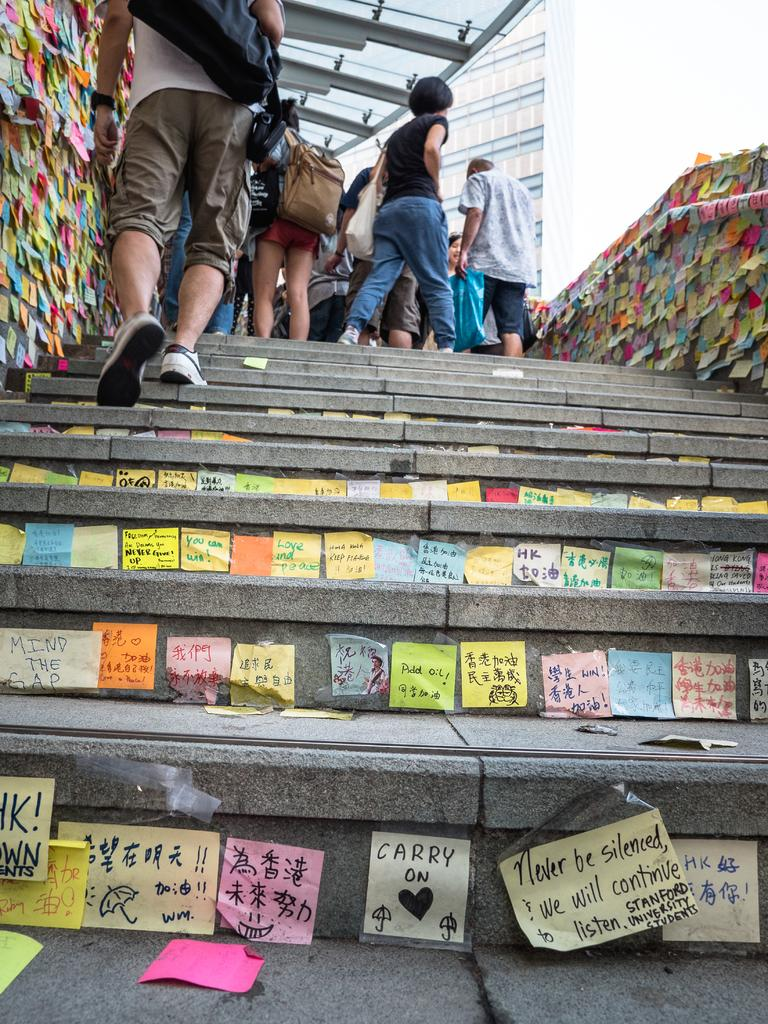<image>
Share a concise interpretation of the image provided. A set of outdoor stairs is covered in sticky notes with one reading Add oil! 